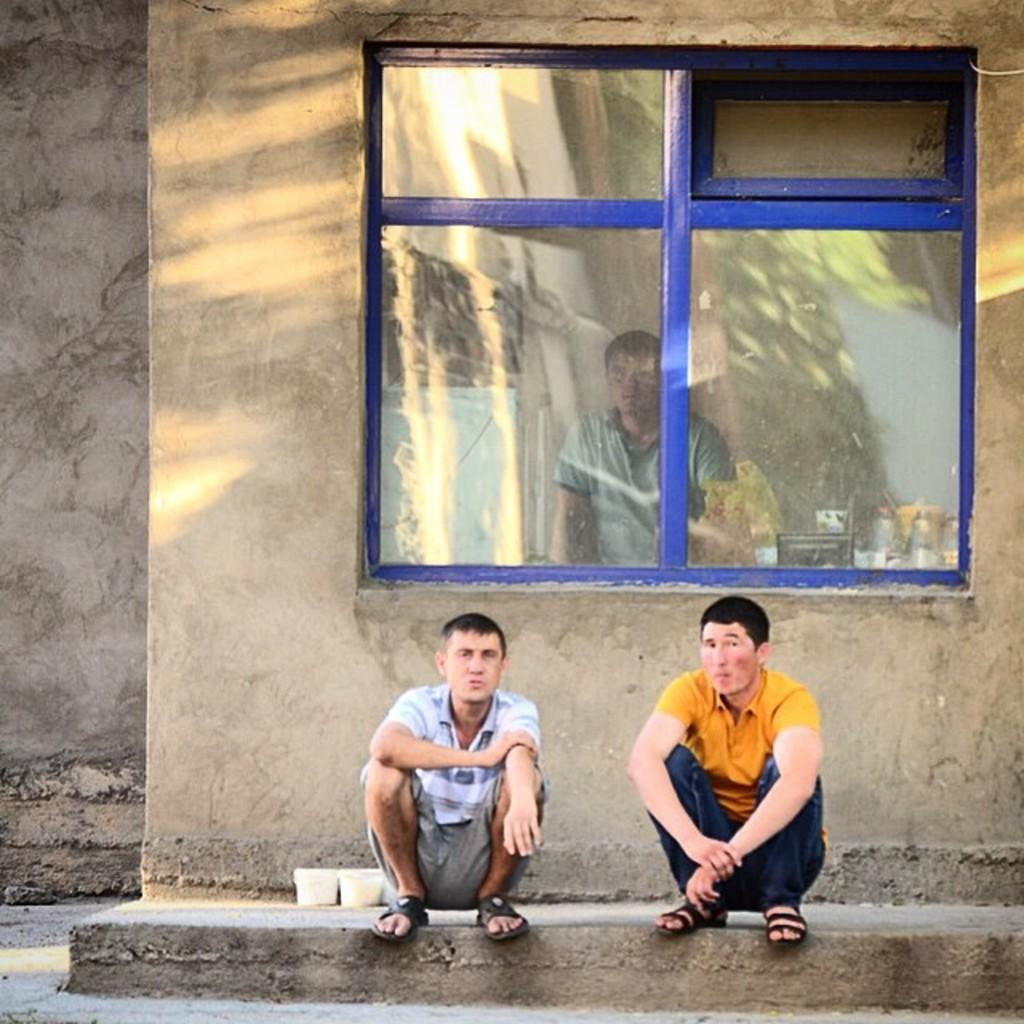How many people are in the image? There are two men in the image. What are the men doing in the image? The men are sitting on the floor. Can you describe any architectural features in the image? Yes, there is a glass window in the image. What type of string can be seen connecting the two men in the image? There is no string connecting the two men in the image. What kind of mine is visible in the background of the image? There is no mine present in the image. 